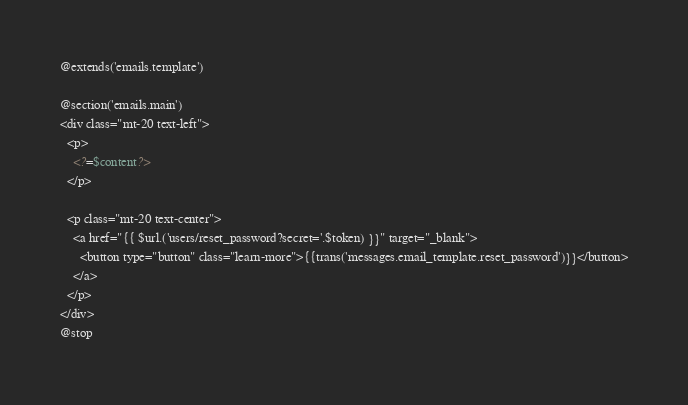<code> <loc_0><loc_0><loc_500><loc_500><_PHP_>@extends('emails.template')

@section('emails.main')
<div class="mt-20 text-left">
  <p>
    <?=$content?>
  </p>
  
  <p class="mt-20 text-center">
    <a href="{{ $url.('users/reset_password?secret='.$token) }}" target="_blank">
      <button type="button" class="learn-more">{{trans('messages.email_template.reset_password')}}</button>
    </a>
  </p>
</div>
@stop

</code> 